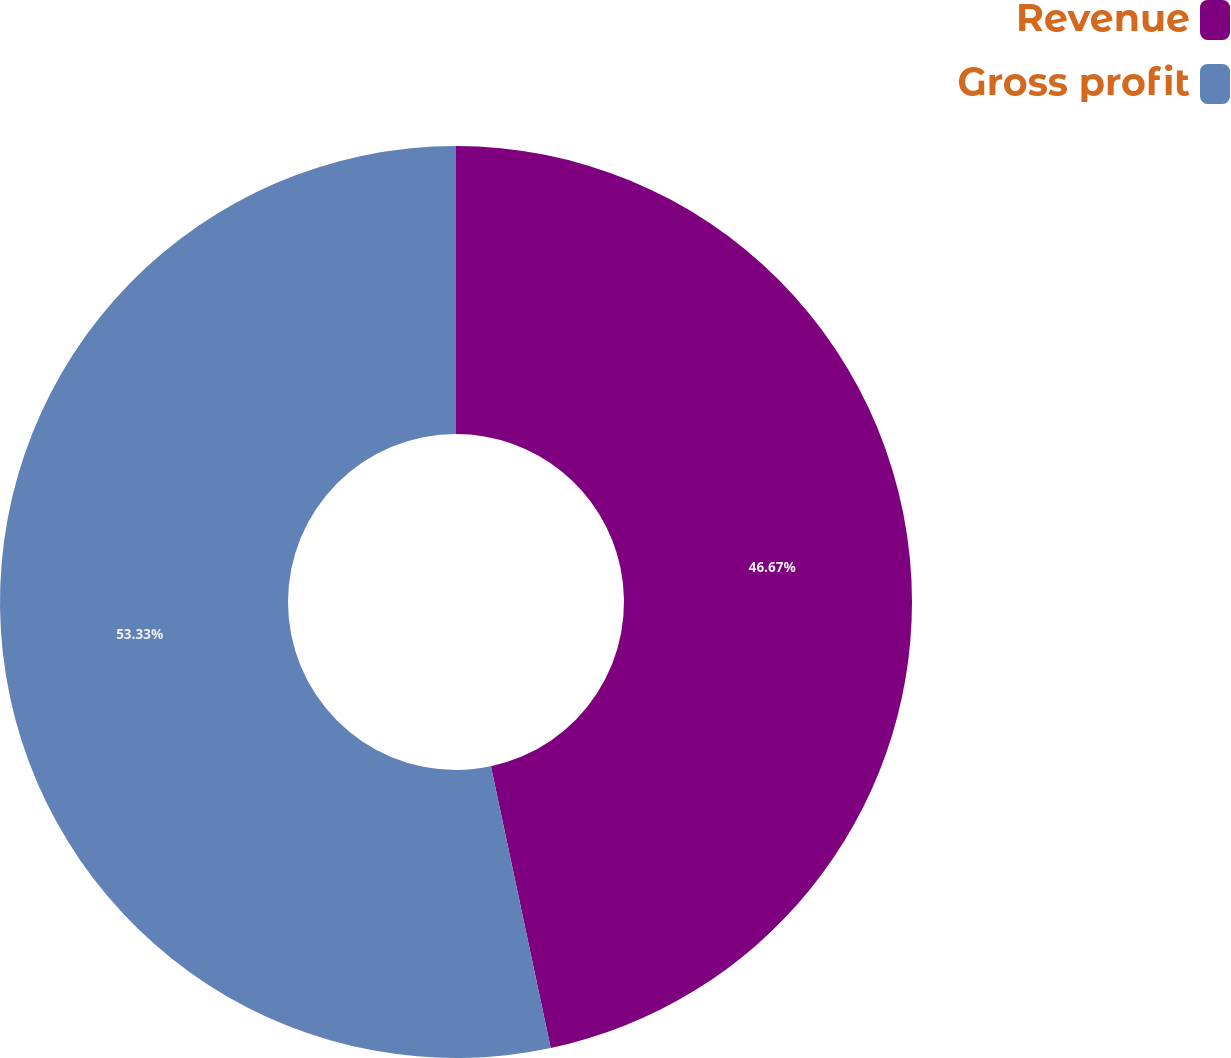<chart> <loc_0><loc_0><loc_500><loc_500><pie_chart><fcel>Revenue<fcel>Gross profit<nl><fcel>46.67%<fcel>53.33%<nl></chart> 